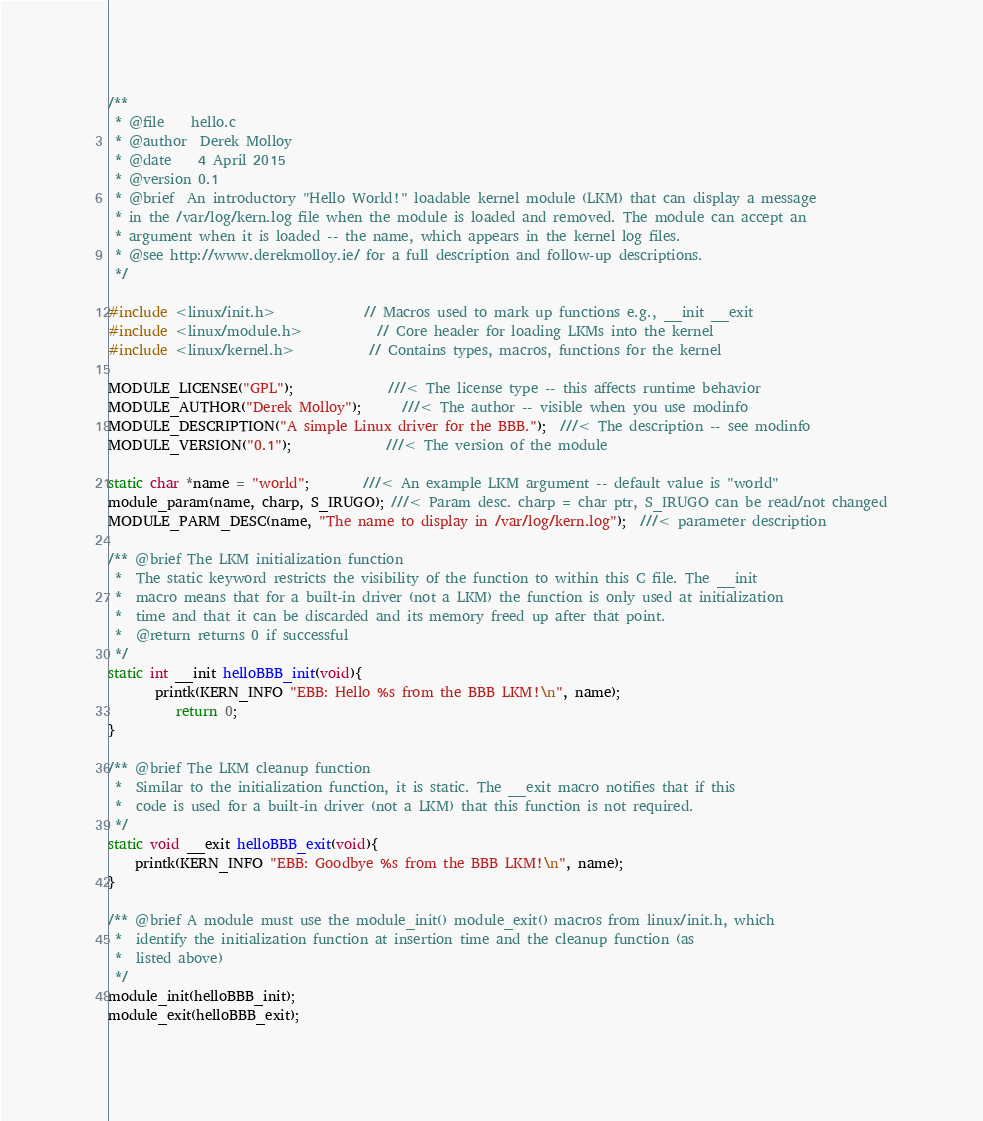<code> <loc_0><loc_0><loc_500><loc_500><_C_>/**
 * @file    hello.c
 * @author  Derek Molloy
 * @date    4 April 2015
 * @version 0.1
 * @brief  An introductory "Hello World!" loadable kernel module (LKM) that can display a message
 * in the /var/log/kern.log file when the module is loaded and removed. The module can accept an
 * argument when it is loaded -- the name, which appears in the kernel log files.
 * @see http://www.derekmolloy.ie/ for a full description and follow-up descriptions.
 */

#include <linux/init.h>             // Macros used to mark up functions e.g., __init __exit
#include <linux/module.h>           // Core header for loading LKMs into the kernel
#include <linux/kernel.h>           // Contains types, macros, functions for the kernel

MODULE_LICENSE("GPL");              ///< The license type -- this affects runtime behavior
MODULE_AUTHOR("Derek Molloy");      ///< The author -- visible when you use modinfo
MODULE_DESCRIPTION("A simple Linux driver for the BBB.");  ///< The description -- see modinfo
MODULE_VERSION("0.1");              ///< The version of the module

static char *name = "world";        ///< An example LKM argument -- default value is "world"
module_param(name, charp, S_IRUGO); ///< Param desc. charp = char ptr, S_IRUGO can be read/not changed
MODULE_PARM_DESC(name, "The name to display in /var/log/kern.log");  ///< parameter description

/** @brief The LKM initialization function
 *  The static keyword restricts the visibility of the function to within this C file. The __init
 *  macro means that for a built-in driver (not a LKM) the function is only used at initialization
 *  time and that it can be discarded and its memory freed up after that point.
 *  @return returns 0 if successful
 */
static int __init helloBBB_init(void){
       printk(KERN_INFO "EBB: Hello %s from the BBB LKM!\n", name);
          return 0;
}

/** @brief The LKM cleanup function
 *  Similar to the initialization function, it is static. The __exit macro notifies that if this
 *  code is used for a built-in driver (not a LKM) that this function is not required.
 */
static void __exit helloBBB_exit(void){
    printk(KERN_INFO "EBB: Goodbye %s from the BBB LKM!\n", name);
}

/** @brief A module must use the module_init() module_exit() macros from linux/init.h, which
 *  identify the initialization function at insertion time and the cleanup function (as
 *  listed above)
 */
module_init(helloBBB_init);
module_exit(helloBBB_exit);
</code> 